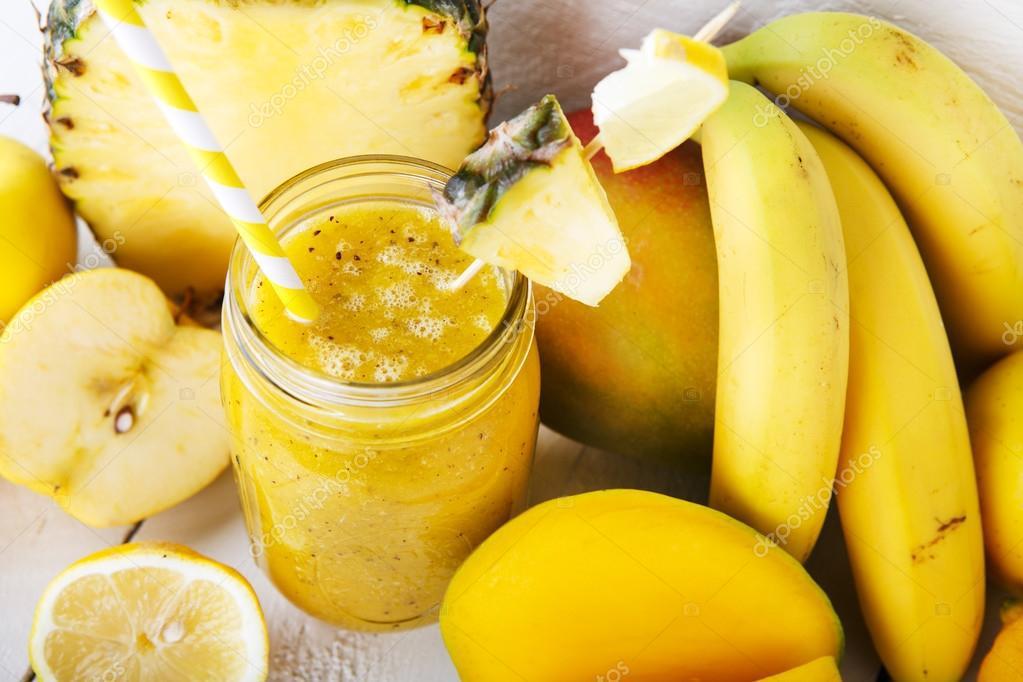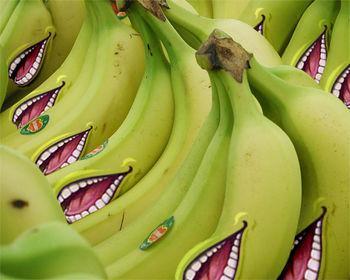The first image is the image on the left, the second image is the image on the right. Analyze the images presented: Is the assertion "One image features a pineapple, bananas and other fruit along with a beverage in a glass, and the other image features only bunches of bananas." valid? Answer yes or no. Yes. The first image is the image on the left, the second image is the image on the right. Evaluate the accuracy of this statement regarding the images: "One image has only bananas and the other has fruit and a fruit smoothie.". Is it true? Answer yes or no. Yes. 